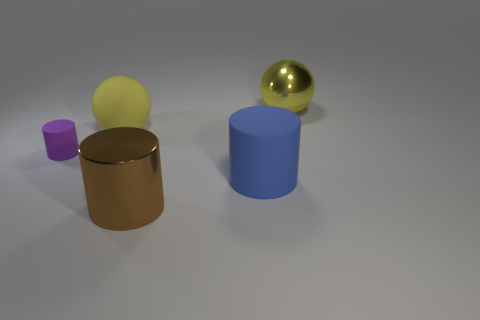Does the tiny rubber object have the same color as the metal object behind the purple rubber cylinder?
Your response must be concise. No. How many other things are the same size as the blue rubber cylinder?
Offer a terse response. 3. What is the size of the other ball that is the same color as the large rubber ball?
Make the answer very short. Large. How many cylinders are large things or brown objects?
Your response must be concise. 2. Is the shape of the rubber thing in front of the tiny purple thing the same as  the big yellow metal object?
Provide a short and direct response. No. Is the number of large yellow metal balls that are right of the yellow metallic ball greater than the number of small things?
Your answer should be very brief. No. What is the color of the rubber sphere that is the same size as the blue matte thing?
Provide a succinct answer. Yellow. What number of things are matte cylinders to the right of the tiny object or large yellow shiny things?
Provide a short and direct response. 2. What is the shape of the object that is the same color as the rubber ball?
Make the answer very short. Sphere. There is a large yellow object that is in front of the yellow object to the right of the yellow rubber thing; what is its material?
Provide a succinct answer. Rubber. 